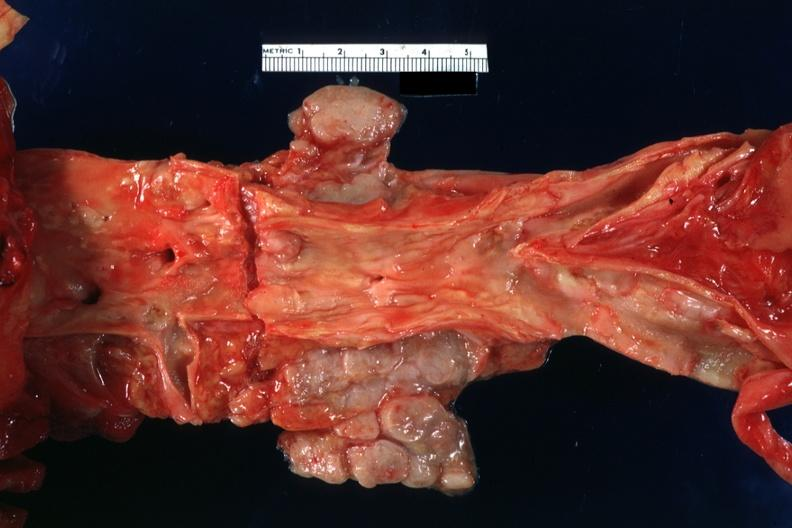what is present?
Answer the question using a single word or phrase. Lymph node 